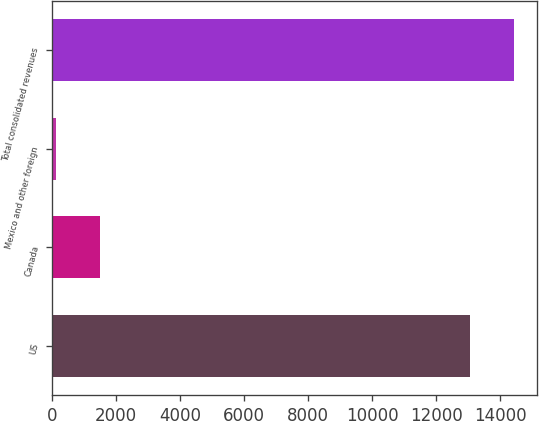Convert chart. <chart><loc_0><loc_0><loc_500><loc_500><bar_chart><fcel>US<fcel>Canada<fcel>Mexico and other foreign<fcel>Total consolidated revenues<nl><fcel>13073<fcel>1486.6<fcel>129<fcel>14430.6<nl></chart> 